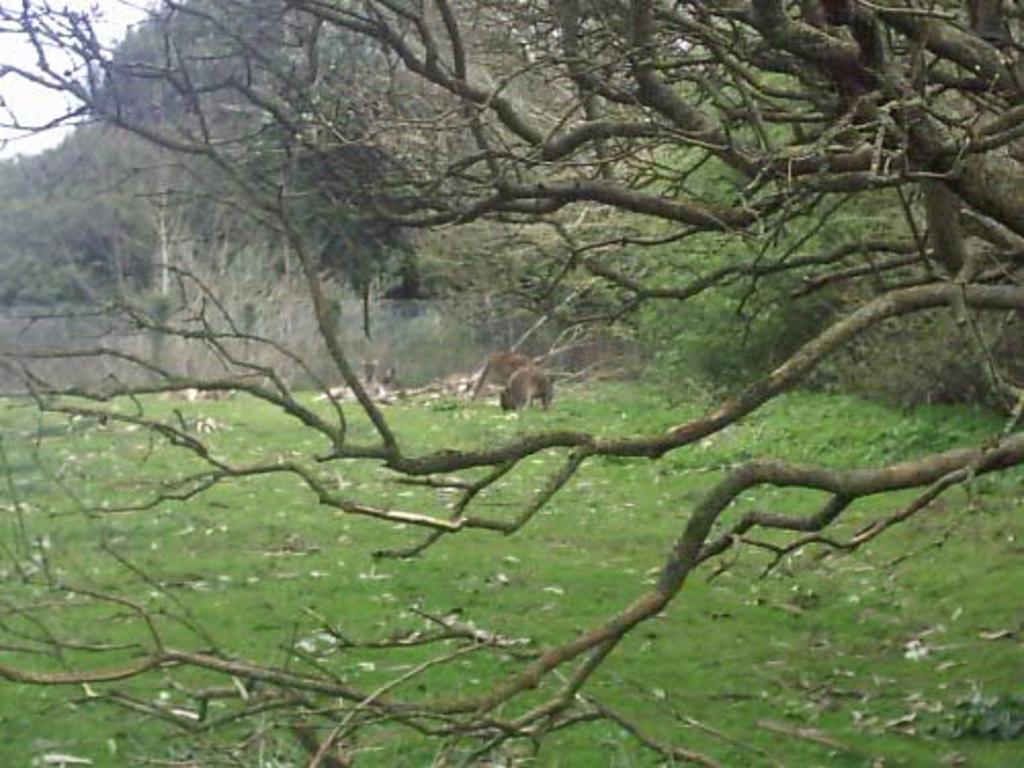Describe this image in one or two sentences. In this image I can see trees, fence and group of animals on the ground. In the left top I can see the sky. This image is taken may be in the forest. 